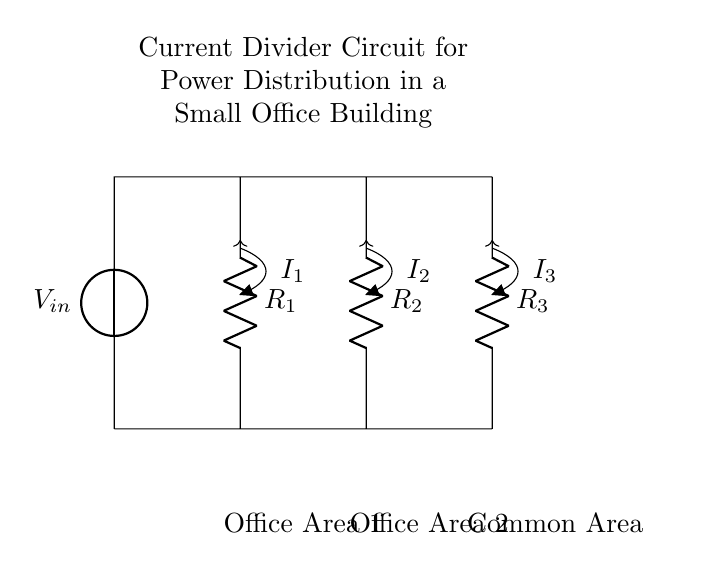What is the source voltage in this circuit? The source voltage is indicated as V_in at the top of the circuit diagram.
Answer: V_in What are the values of the resistors in the circuit? The values of the resistors are given as R_1, R_2, and R_3, but the exact numerical values are not specified in the diagram.
Answer: R_1, R_2, R_3 How many branches are there in the current divider circuit? The circuit has three branches, each corresponding to one of the resistors where the current can divide.
Answer: Three What happens to the total current when it enters the divider? The total current splits into three currents (I_1, I_2, I_3) flowing through each resistor, based on their resistance values.
Answer: It splits Which area receives the current from resistor R_2? The current from resistor R_2 supplies power to Office Area 2, as indicated in the diagram.
Answer: Office Area 2 How does the current division depend on resistance? The current through each resistor is inversely proportional to its resistance; lower resistance results in greater current flow through that path.
Answer: Inversely proportional 